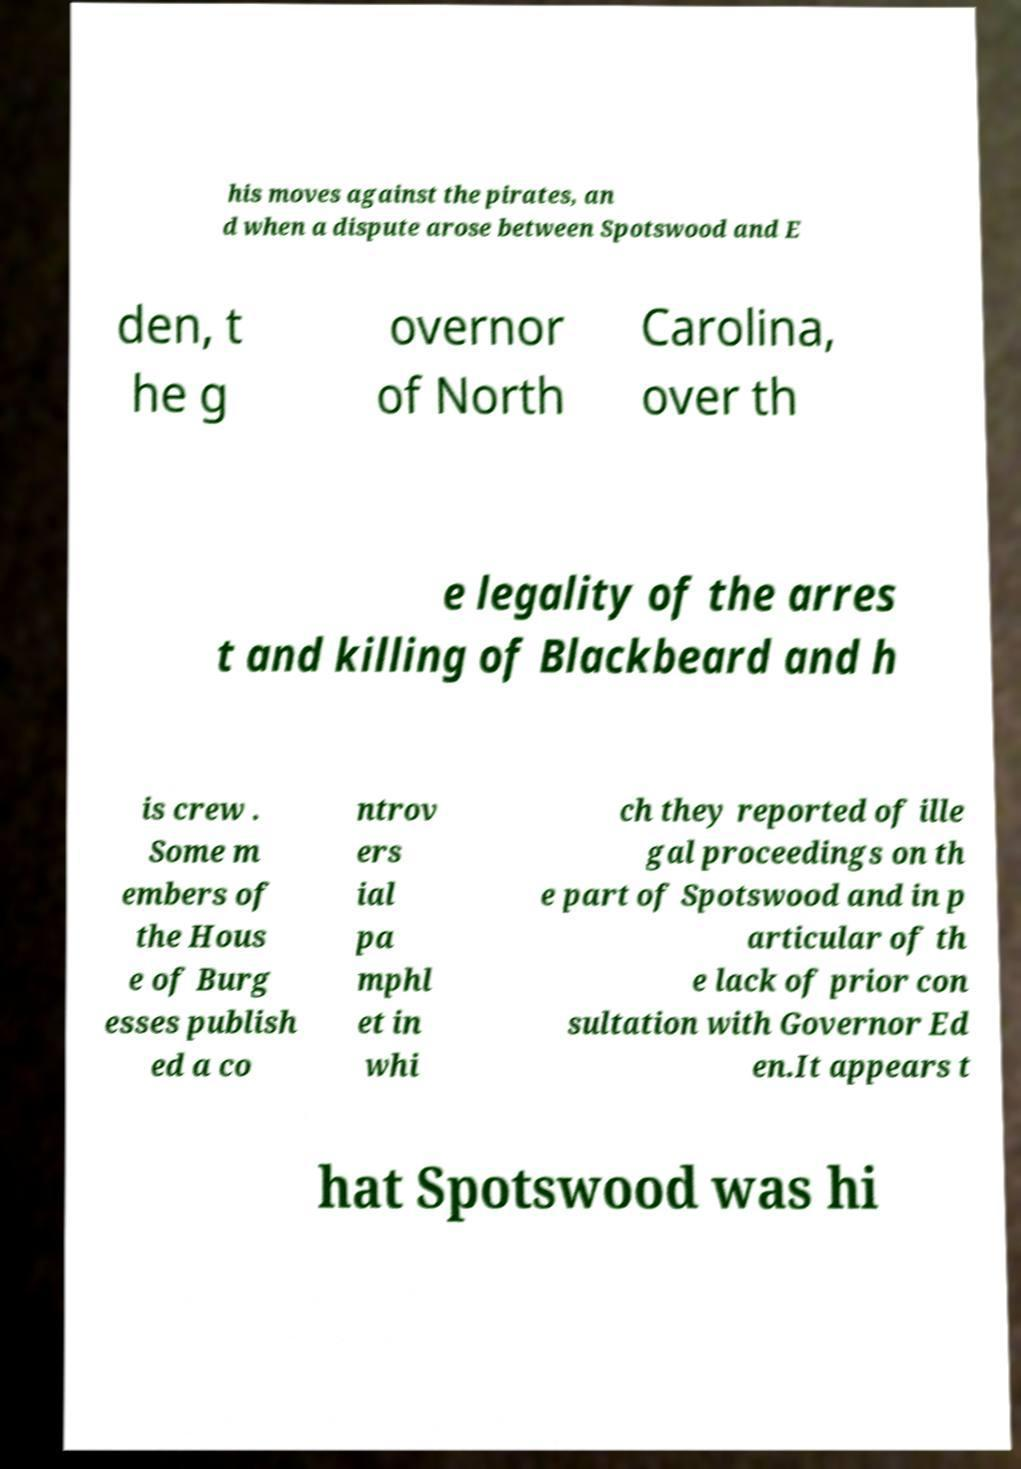Please identify and transcribe the text found in this image. his moves against the pirates, an d when a dispute arose between Spotswood and E den, t he g overnor of North Carolina, over th e legality of the arres t and killing of Blackbeard and h is crew . Some m embers of the Hous e of Burg esses publish ed a co ntrov ers ial pa mphl et in whi ch they reported of ille gal proceedings on th e part of Spotswood and in p articular of th e lack of prior con sultation with Governor Ed en.It appears t hat Spotswood was hi 